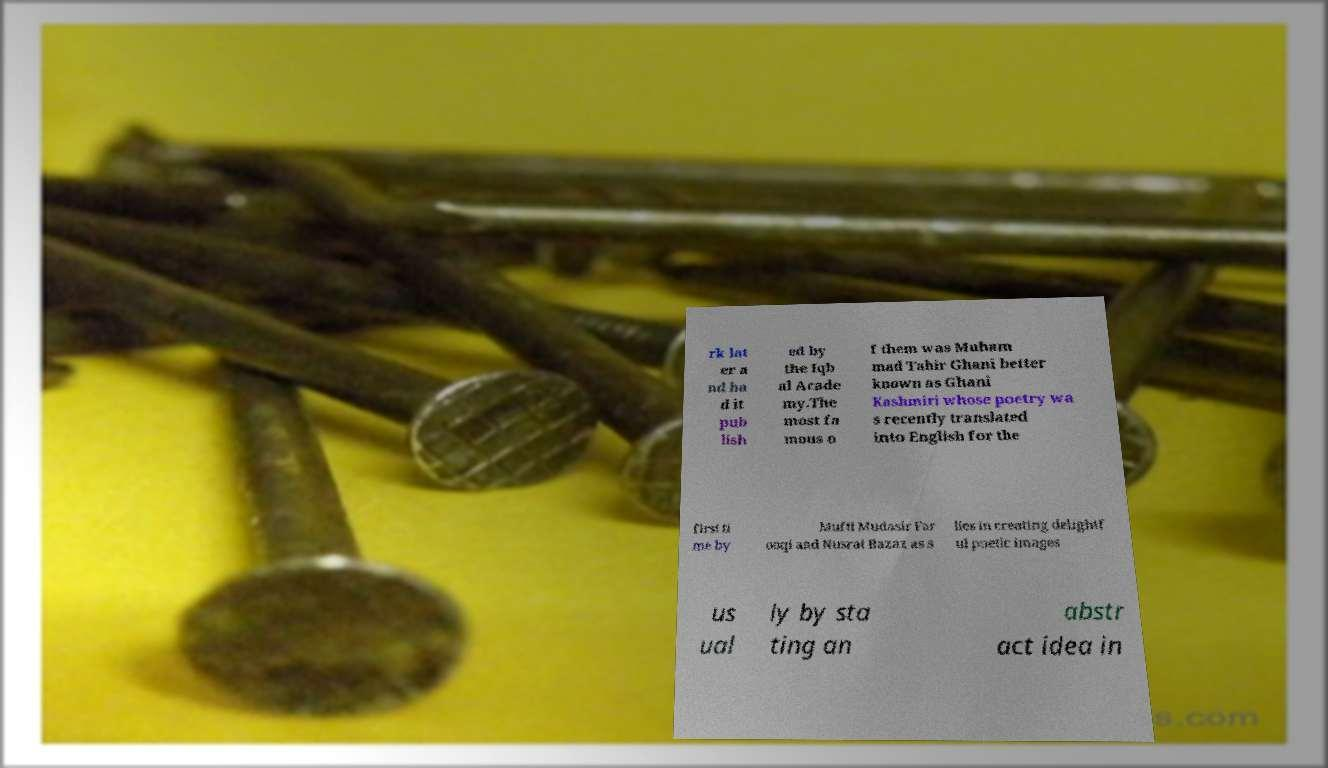I need the written content from this picture converted into text. Can you do that? rk lat er a nd ha d it pub lish ed by the Iqb al Acade my.The most fa mous o f them was Muham mad Tahir Ghani better known as Ghani Kashmiri whose poetry wa s recently translated into English for the first ti me by Mufti Mudasir Far ooqi and Nusrat Bazaz as s lies in creating delightf ul poetic images us ual ly by sta ting an abstr act idea in 